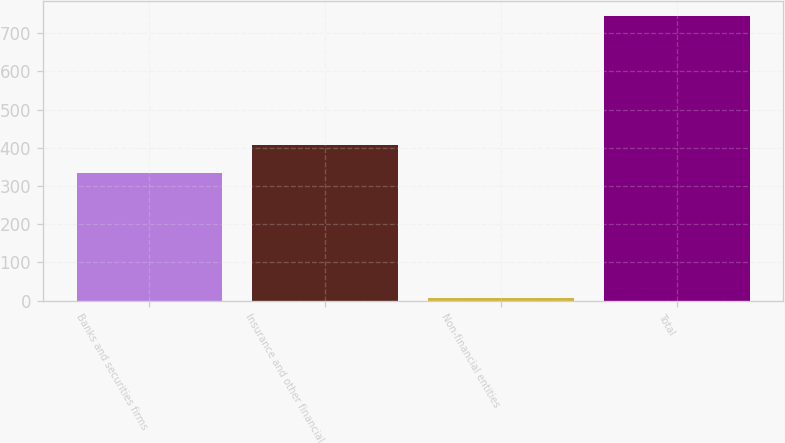Convert chart to OTSL. <chart><loc_0><loc_0><loc_500><loc_500><bar_chart><fcel>Banks and securities firms<fcel>Insurance and other financial<fcel>Non-financial entities<fcel>Total<nl><fcel>333<fcel>406.8<fcel>8<fcel>746<nl></chart> 